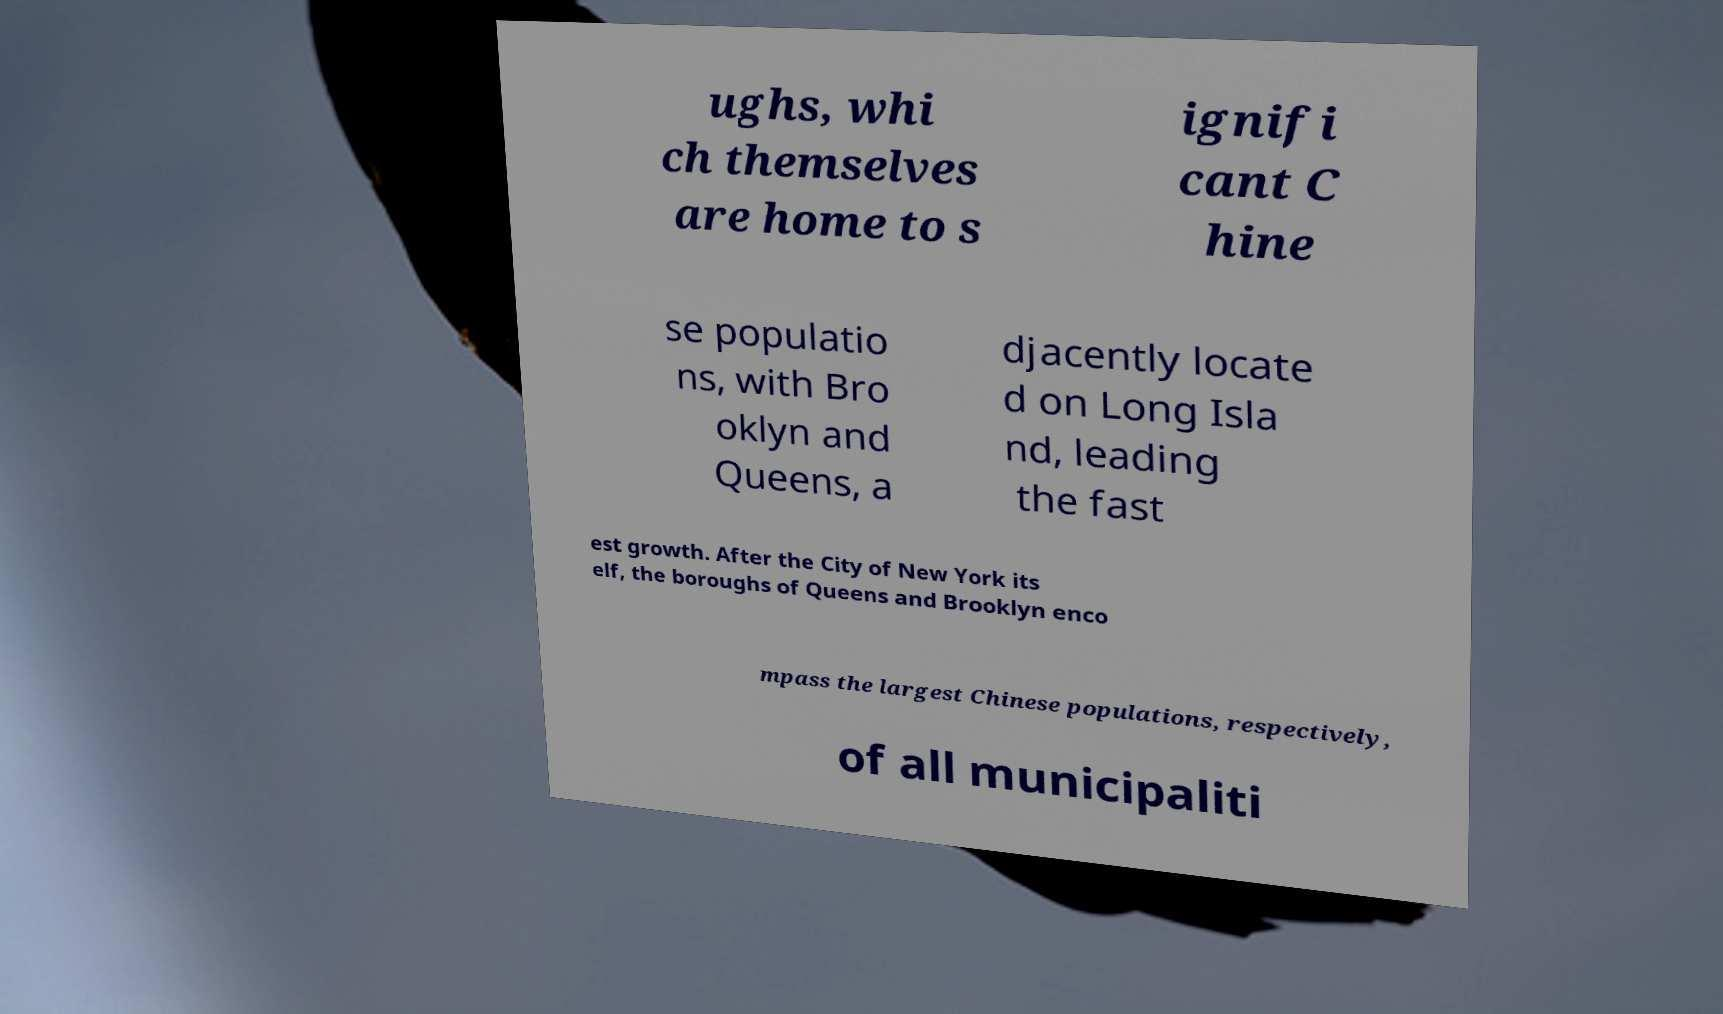What messages or text are displayed in this image? I need them in a readable, typed format. ughs, whi ch themselves are home to s ignifi cant C hine se populatio ns, with Bro oklyn and Queens, a djacently locate d on Long Isla nd, leading the fast est growth. After the City of New York its elf, the boroughs of Queens and Brooklyn enco mpass the largest Chinese populations, respectively, of all municipaliti 